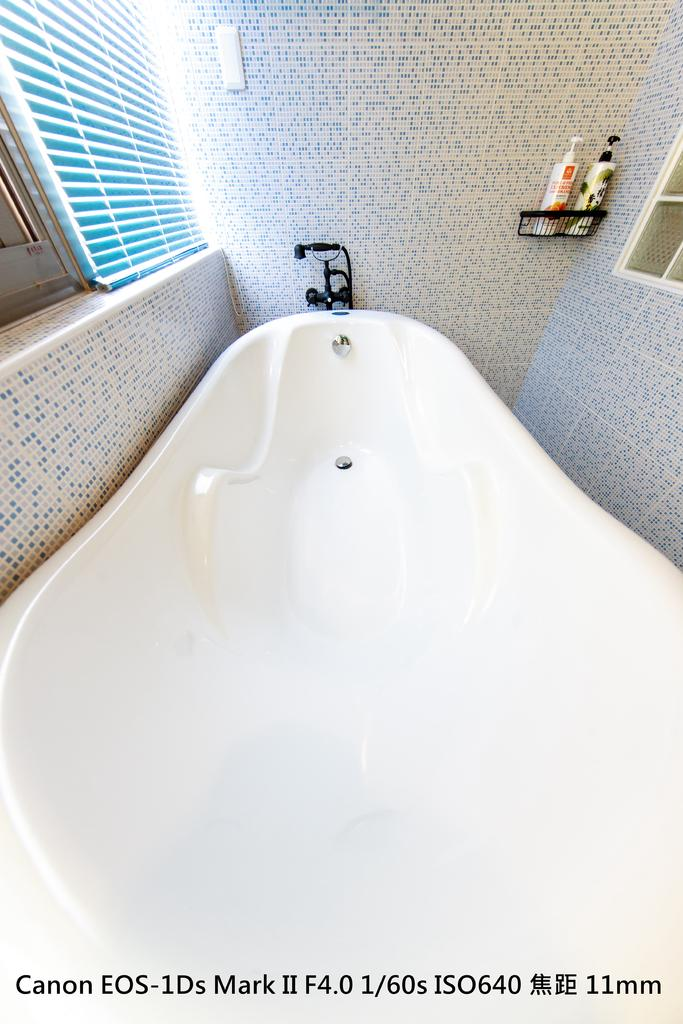What is the main object in the center of the image? There is a bathtub in the center of the image. What color is the bathtub? The bathtub is white. What can be seen in the background of the image? There is a wall, a window blind, a tap, spray bottles, and other unspecified objects in the background of the image. How does the bathtub use its muscles to lift heavy objects in the image? The bathtub does not have muscles and cannot lift heavy objects; it is an inanimate object. 